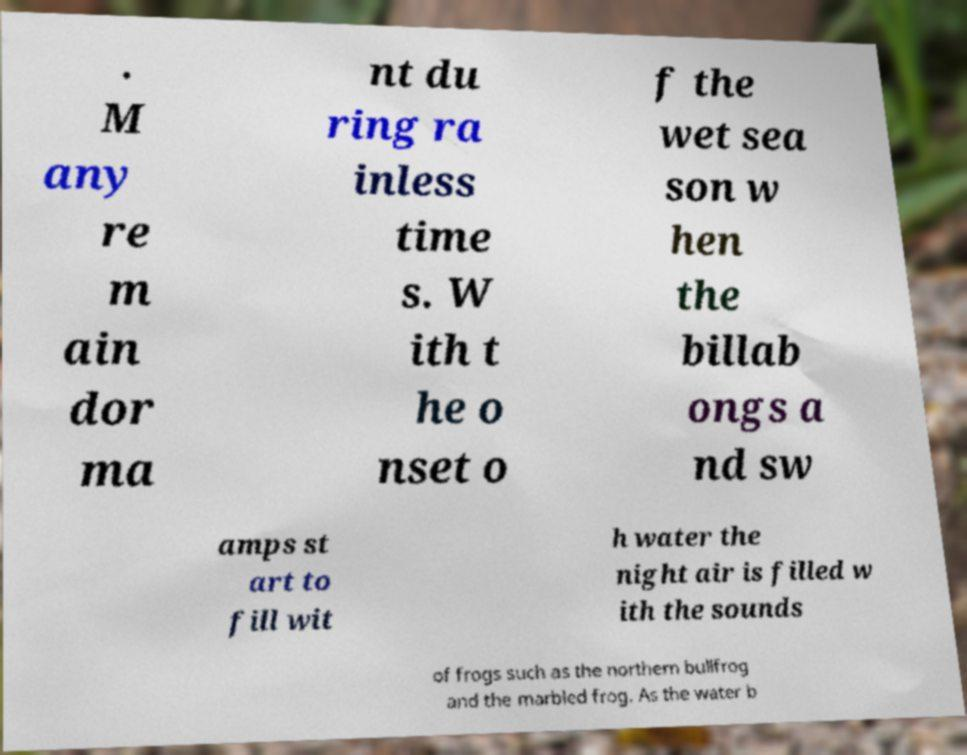For documentation purposes, I need the text within this image transcribed. Could you provide that? . M any re m ain dor ma nt du ring ra inless time s. W ith t he o nset o f the wet sea son w hen the billab ongs a nd sw amps st art to fill wit h water the night air is filled w ith the sounds of frogs such as the northern bullfrog and the marbled frog. As the water b 